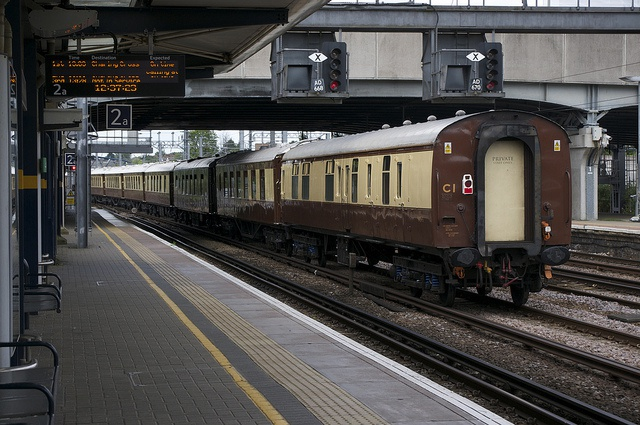Describe the objects in this image and their specific colors. I can see train in black, darkgray, and gray tones, bench in black and gray tones, bench in black and gray tones, traffic light in black and gray tones, and traffic light in black and gray tones in this image. 